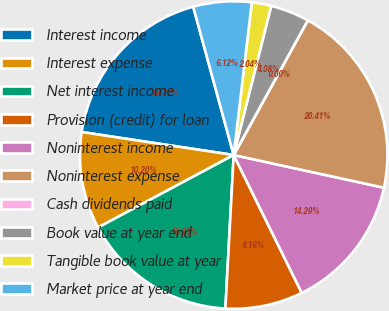Convert chart to OTSL. <chart><loc_0><loc_0><loc_500><loc_500><pie_chart><fcel>Interest income<fcel>Interest expense<fcel>Net interest income<fcel>Provision (credit) for loan<fcel>Noninterest income<fcel>Noninterest expense<fcel>Cash dividends paid<fcel>Book value at year end<fcel>Tangible book value at year<fcel>Market price at year end<nl><fcel>18.37%<fcel>10.2%<fcel>16.33%<fcel>8.16%<fcel>14.29%<fcel>20.41%<fcel>0.0%<fcel>4.08%<fcel>2.04%<fcel>6.12%<nl></chart> 